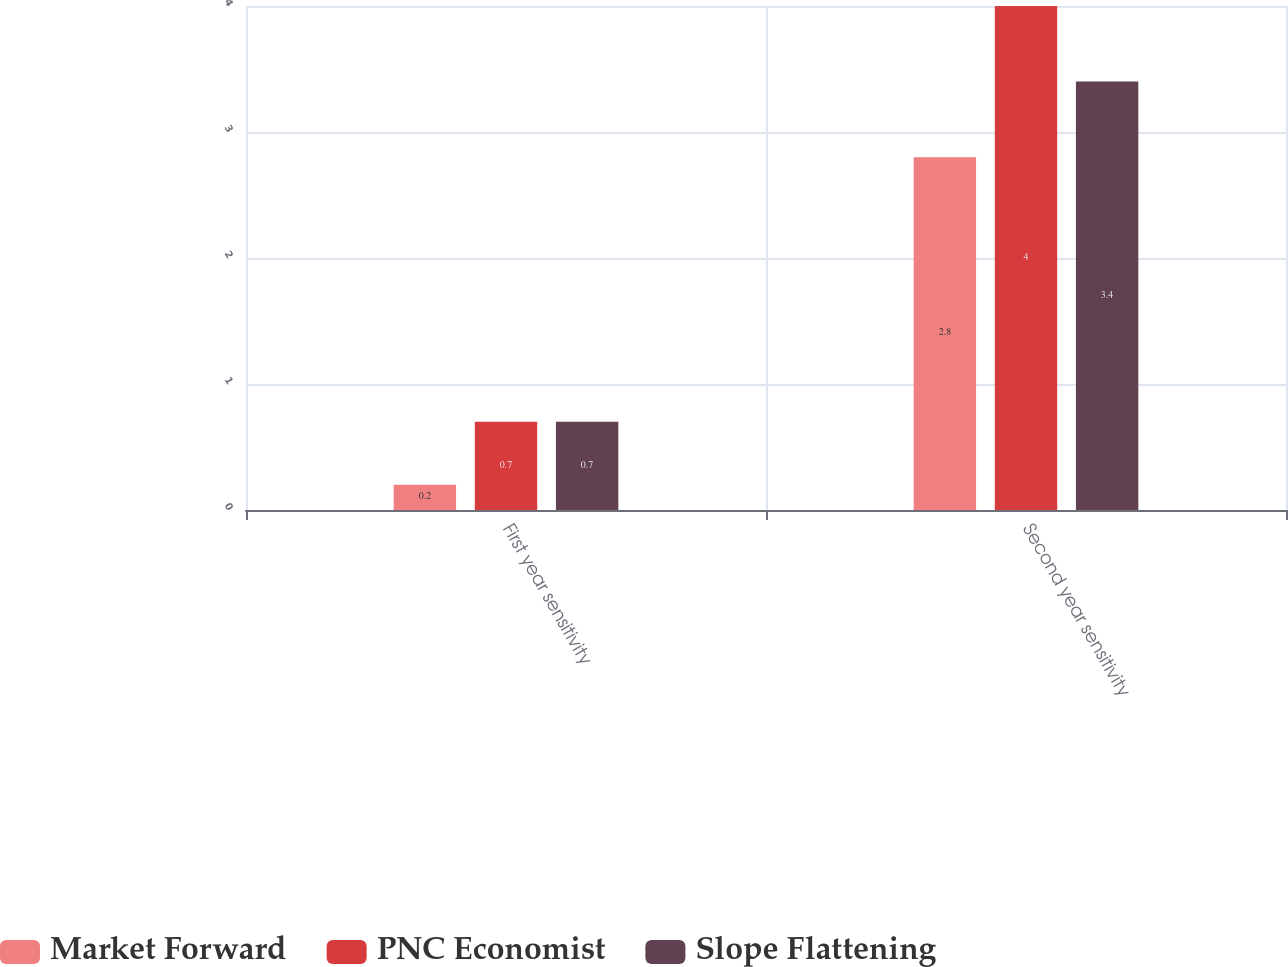Convert chart to OTSL. <chart><loc_0><loc_0><loc_500><loc_500><stacked_bar_chart><ecel><fcel>First year sensitivity<fcel>Second year sensitivity<nl><fcel>Market Forward<fcel>0.2<fcel>2.8<nl><fcel>PNC Economist<fcel>0.7<fcel>4<nl><fcel>Slope Flattening<fcel>0.7<fcel>3.4<nl></chart> 